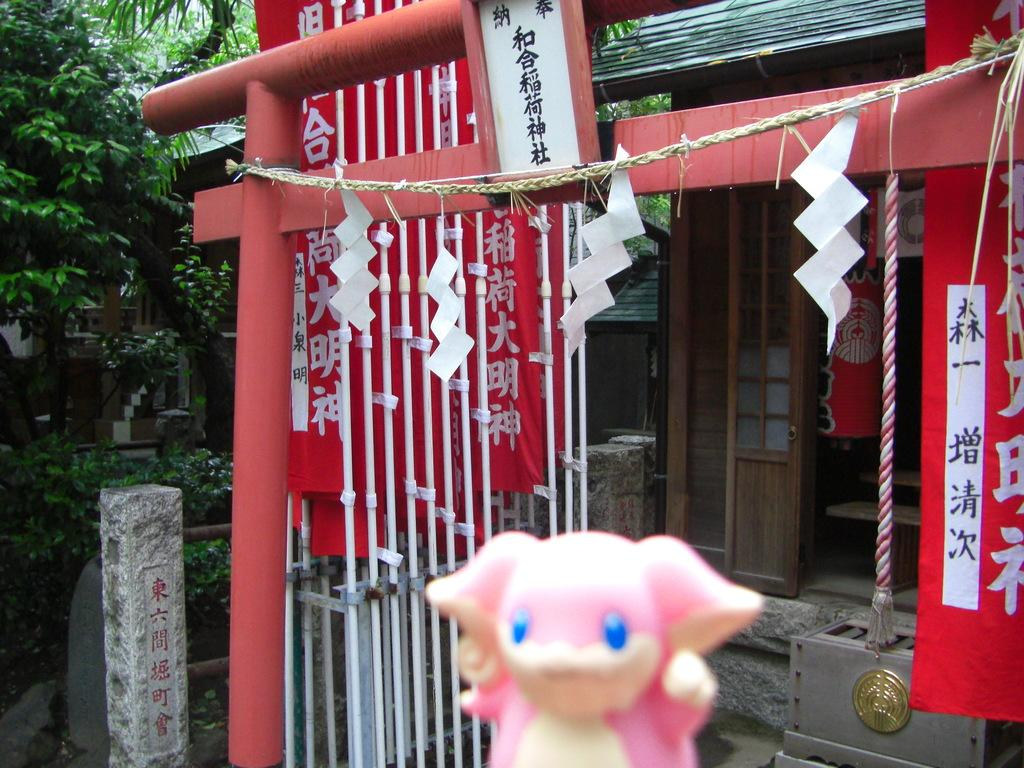What is the main object in the front of the image? There is a toy in the front of the image. What can be seen in the distance in the image? There are trees and sheds in the background of the image. Are there any additional decorations or signs in the background? Yes, there are banners visible in the background of the image. What flavor of glue is being used to attach the pets to the toy in the image? There are no pets or glue present in the image. 